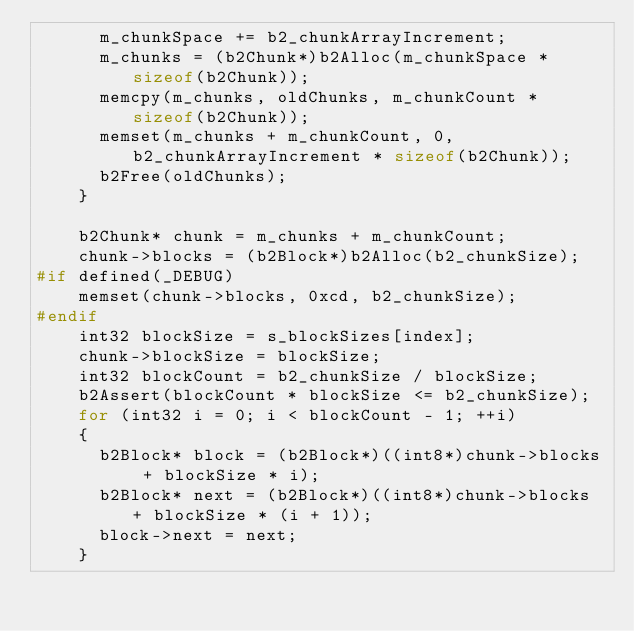<code> <loc_0><loc_0><loc_500><loc_500><_C++_>			m_chunkSpace += b2_chunkArrayIncrement;
			m_chunks = (b2Chunk*)b2Alloc(m_chunkSpace * sizeof(b2Chunk));
			memcpy(m_chunks, oldChunks, m_chunkCount * sizeof(b2Chunk));
			memset(m_chunks + m_chunkCount, 0, b2_chunkArrayIncrement * sizeof(b2Chunk));
			b2Free(oldChunks);
		}

		b2Chunk* chunk = m_chunks + m_chunkCount;
		chunk->blocks = (b2Block*)b2Alloc(b2_chunkSize);
#if defined(_DEBUG)
		memset(chunk->blocks, 0xcd, b2_chunkSize);
#endif
		int32 blockSize = s_blockSizes[index];
		chunk->blockSize = blockSize;
		int32 blockCount = b2_chunkSize / blockSize;
		b2Assert(blockCount * blockSize <= b2_chunkSize);
		for (int32 i = 0; i < blockCount - 1; ++i)
		{
			b2Block* block = (b2Block*)((int8*)chunk->blocks + blockSize * i);
			b2Block* next = (b2Block*)((int8*)chunk->blocks + blockSize * (i + 1));
			block->next = next;
		}</code> 